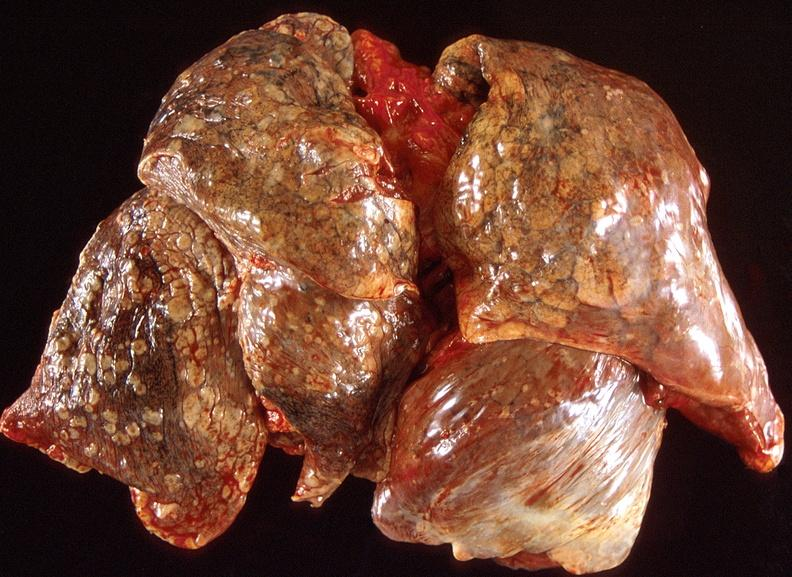s infarct present?
Answer the question using a single word or phrase. No 